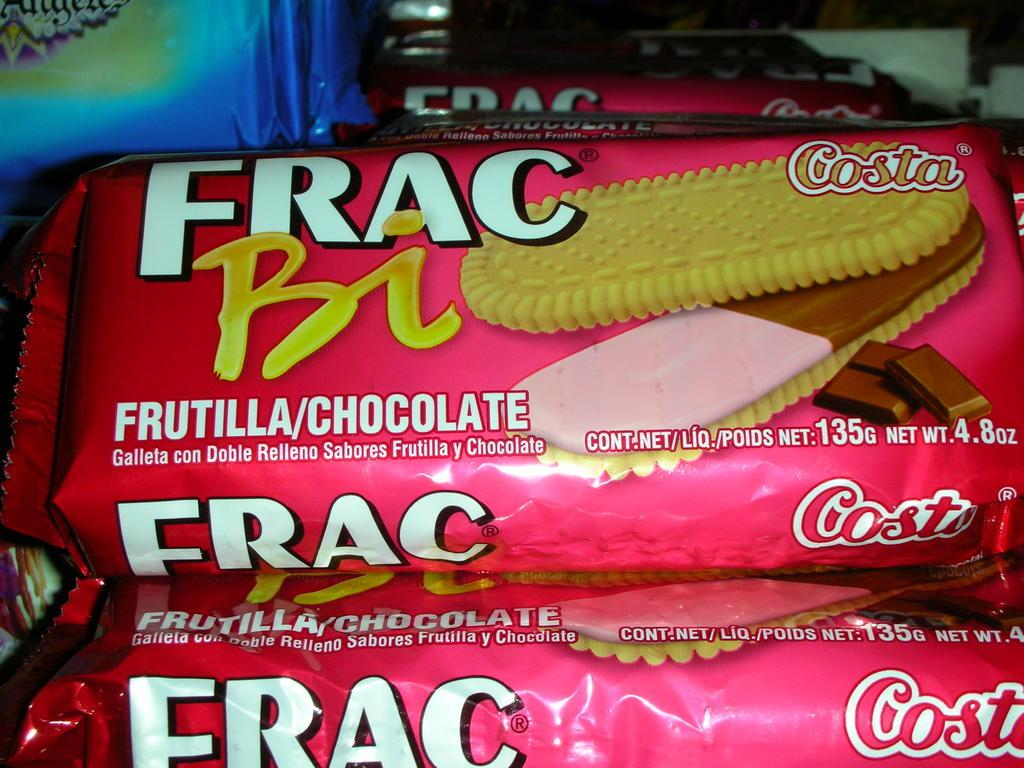What is present in the image that is packaged? There are packets in the image. What can be seen on the surface of the packets? The packets have images of food on them. What else is present on the packets besides the images? There is text on the packets. Where is the meeting taking place in the image? There is no meeting present in the image; it only features packets with images of food and text. 